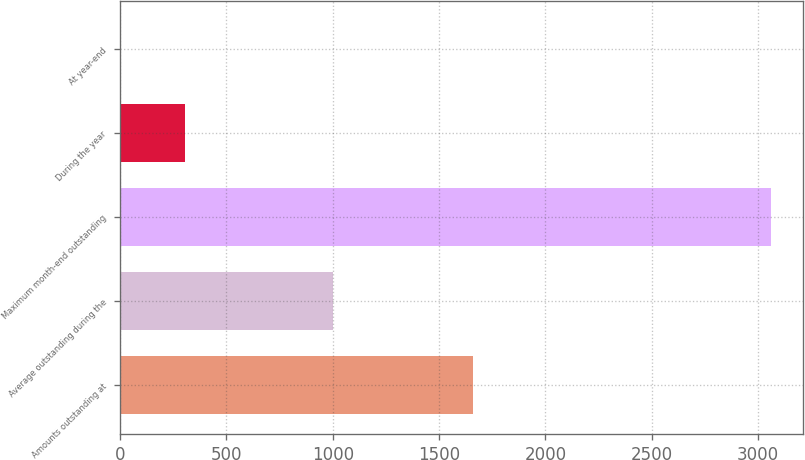Convert chart to OTSL. <chart><loc_0><loc_0><loc_500><loc_500><bar_chart><fcel>Amounts outstanding at<fcel>Average outstanding during the<fcel>Maximum month-end outstanding<fcel>During the year<fcel>At year-end<nl><fcel>1660<fcel>1002<fcel>3060<fcel>306.33<fcel>0.37<nl></chart> 